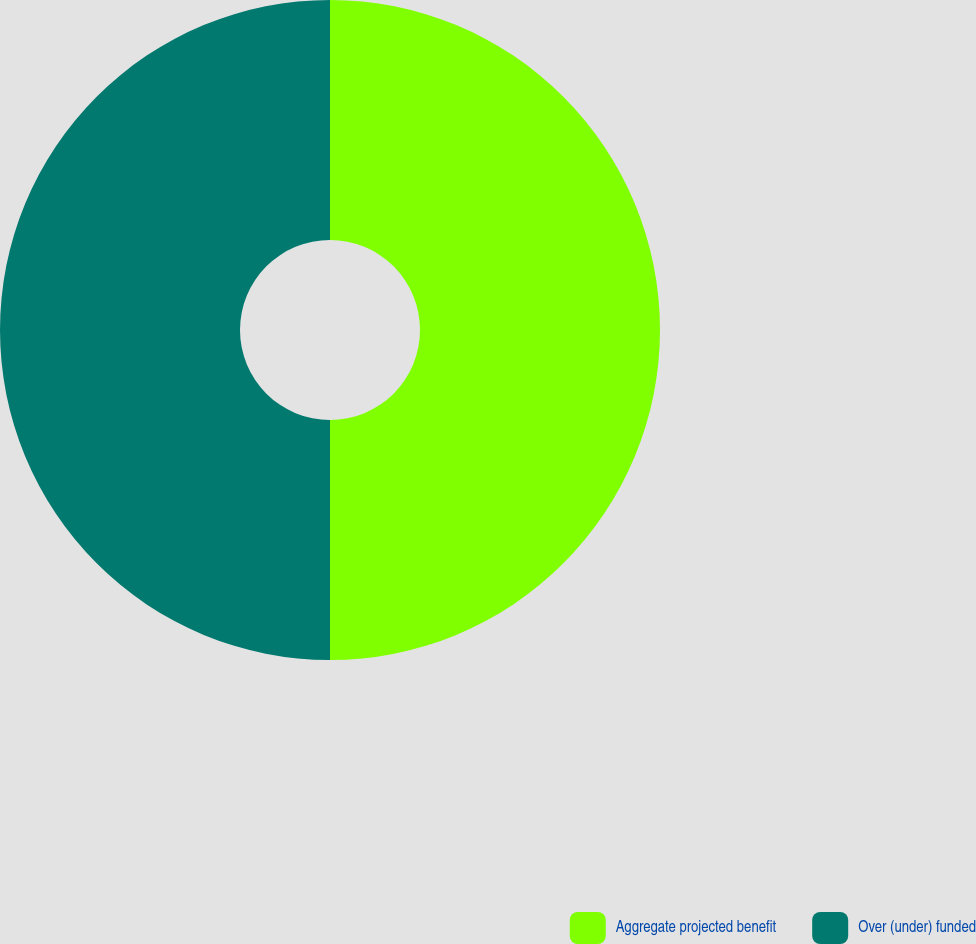<chart> <loc_0><loc_0><loc_500><loc_500><pie_chart><fcel>Aggregate projected benefit<fcel>Over (under) funded<nl><fcel>50.0%<fcel>50.0%<nl></chart> 